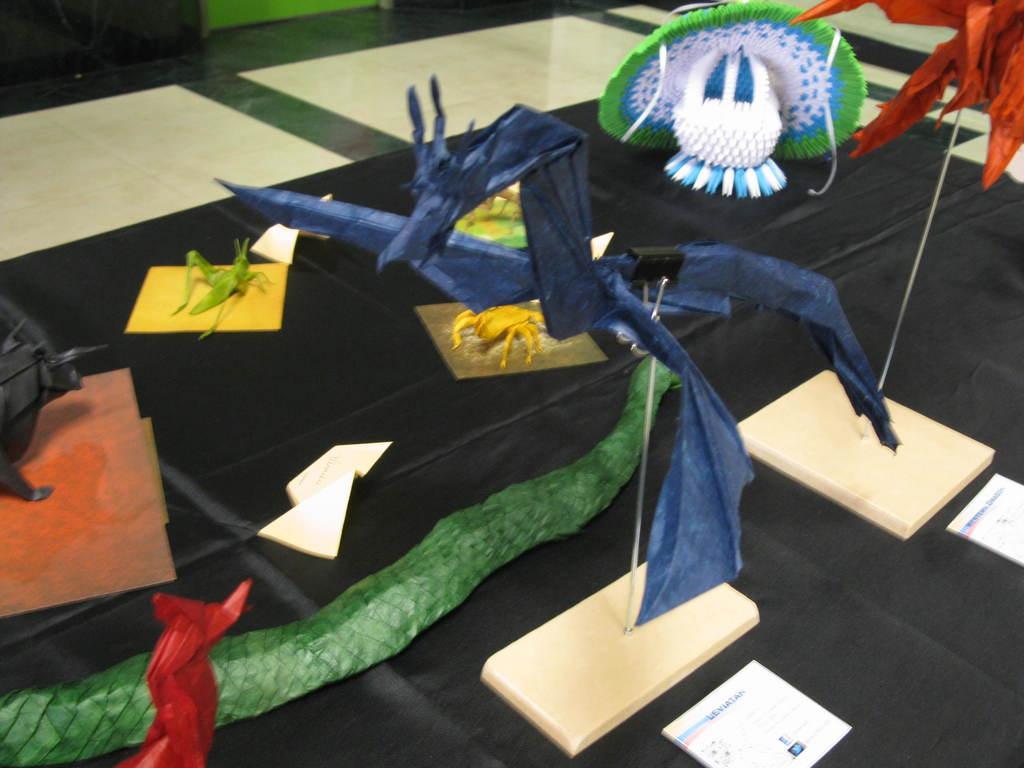How would you summarize this image in a sentence or two? In this image there are few objects on the black color surface. At the bottom of the image there is a floor. 